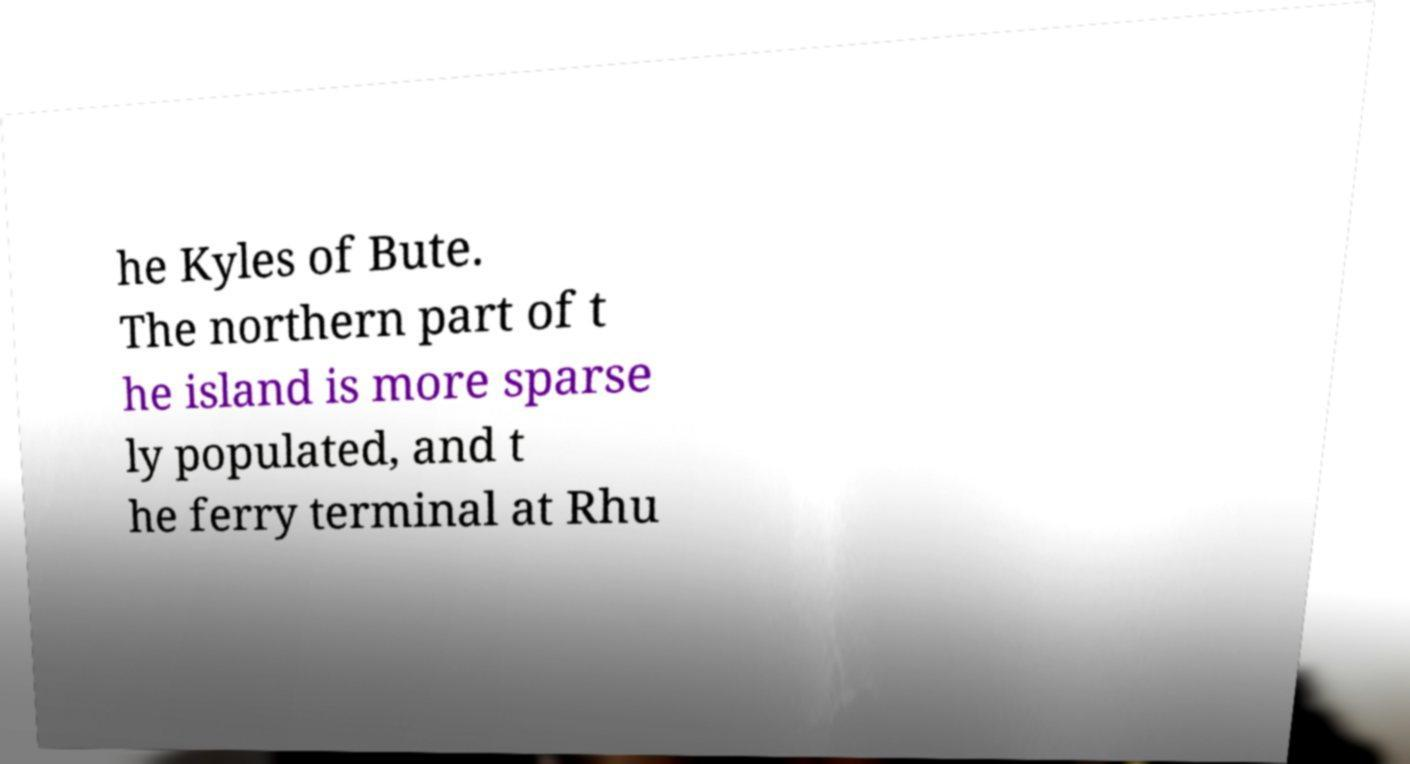Could you extract and type out the text from this image? he Kyles of Bute. The northern part of t he island is more sparse ly populated, and t he ferry terminal at Rhu 